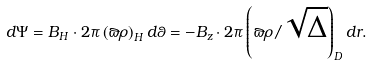<formula> <loc_0><loc_0><loc_500><loc_500>d \Psi = B _ { H } \cdot 2 \pi \left ( { \varpi \rho } \right ) _ { H } d \theta = - B _ { z } \cdot 2 \pi \left ( { \varpi \rho / \sqrt { \Delta } } \right ) _ { D } d r .</formula> 